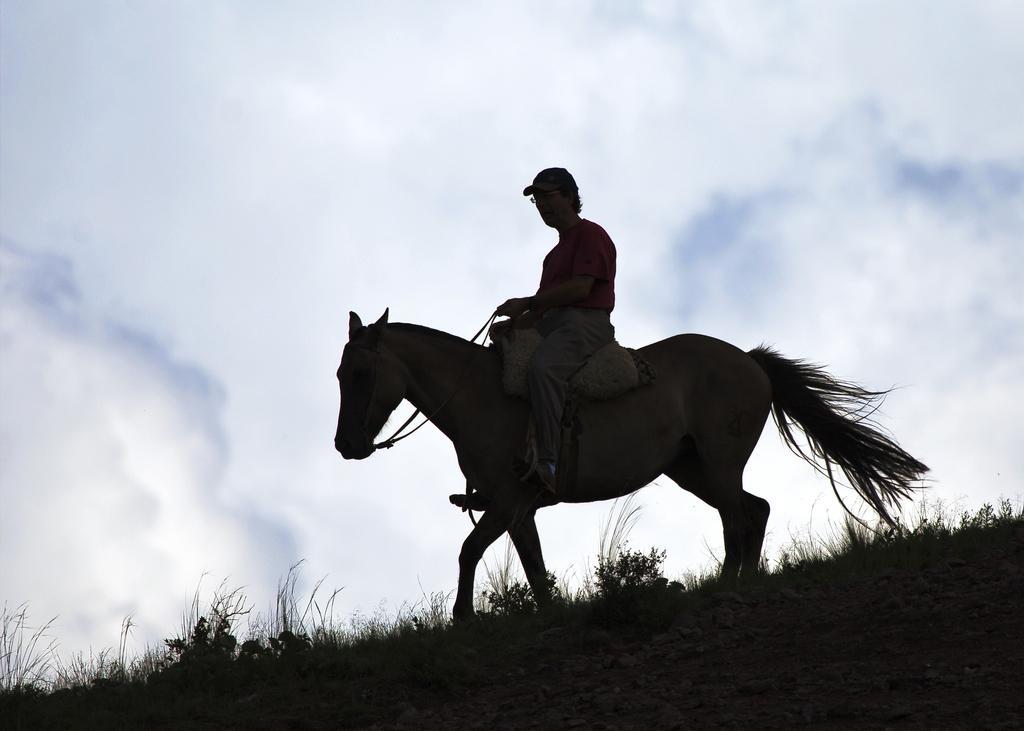Can you describe this image briefly? This image consists of a man sitting on a horse. At the bottom, there is a ground. In the background, there are clouds in the sky. The man is wearing a cap. 